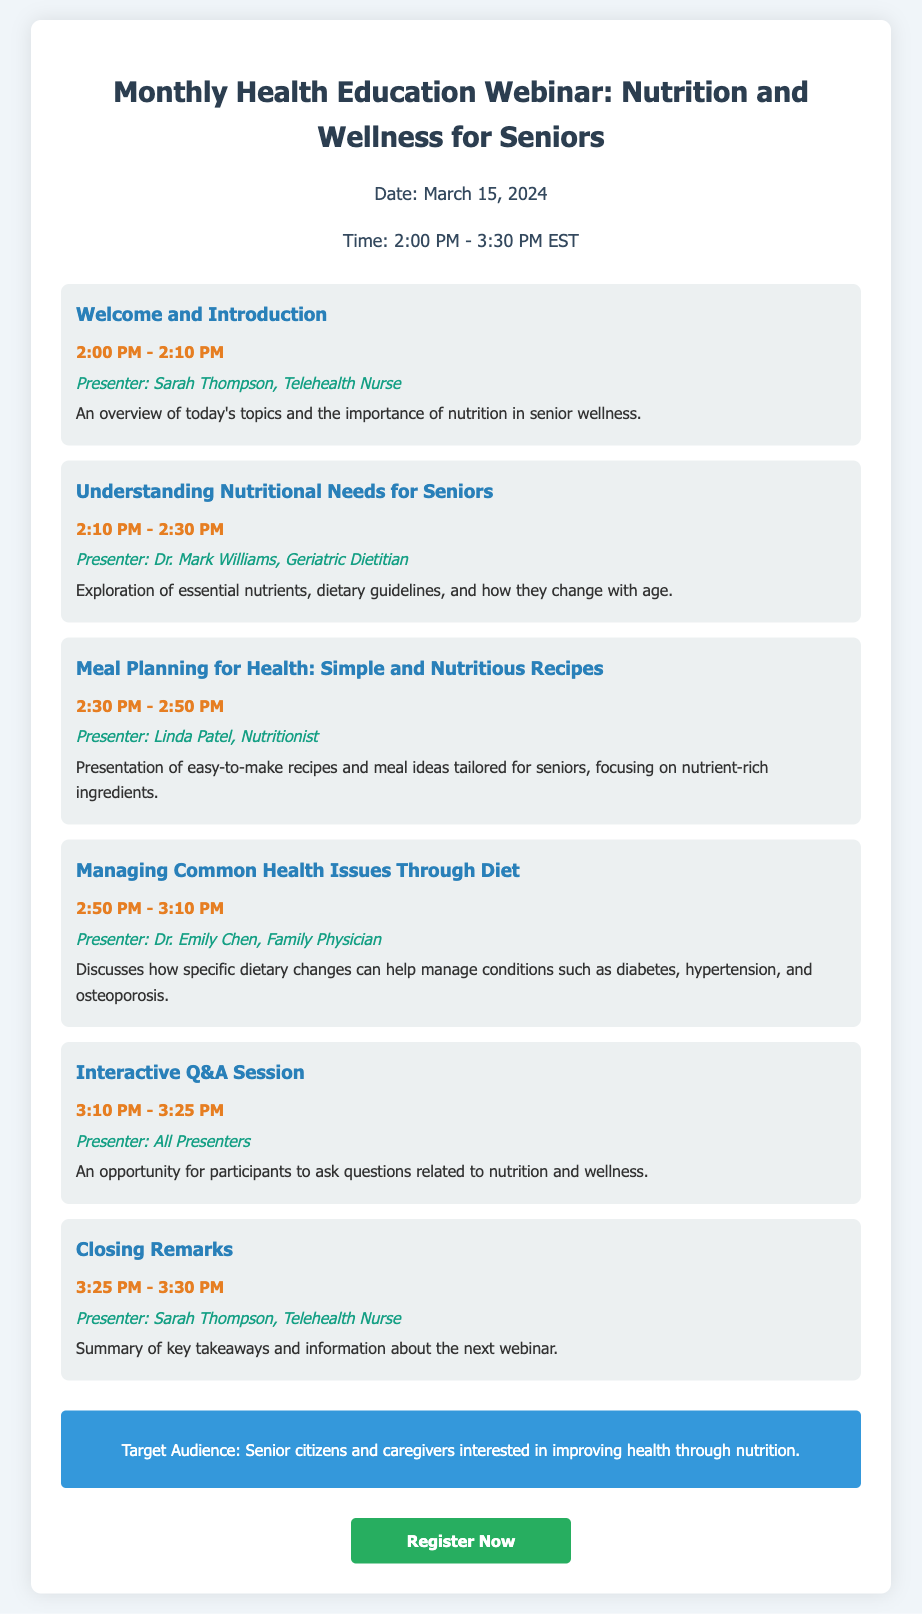What is the date of the webinar? The date of the webinar is explicitly mentioned in the document as March 15, 2024.
Answer: March 15, 2024 Who is the presenter for the first agenda item? The first agenda item lists Sarah Thompson as the presenter.
Answer: Sarah Thompson What is the duration of the Interactive Q&A Session? By examining the timings, the Interactive Q&A Session runs from 3:10 PM to 3:25 PM, which implies a duration of 15 minutes.
Answer: 15 minutes Which health issues are discussed in relation to diet? The document states that dietary changes can help manage conditions such as diabetes, hypertension, and osteoporosis.
Answer: diabetes, hypertension, osteoporosis What is the target audience for the webinar? The target audience is specified as senior citizens and caregivers interested in improving health through nutrition.
Answer: Senior citizens and caregivers What type of presentation is included in the agenda? Considering the structure of the document, it includes presentations, discussions, and an interactive Q&A session.
Answer: Presentations and interactive Q&A session What is the time of the webinar? The time for the webinar is clearly mentioned as 2:00 PM - 3:30 PM EST.
Answer: 2:00 PM - 3:30 PM EST How many agenda items are there in total? After reviewing the agenda, there are six distinct agenda items listed.
Answer: Six 